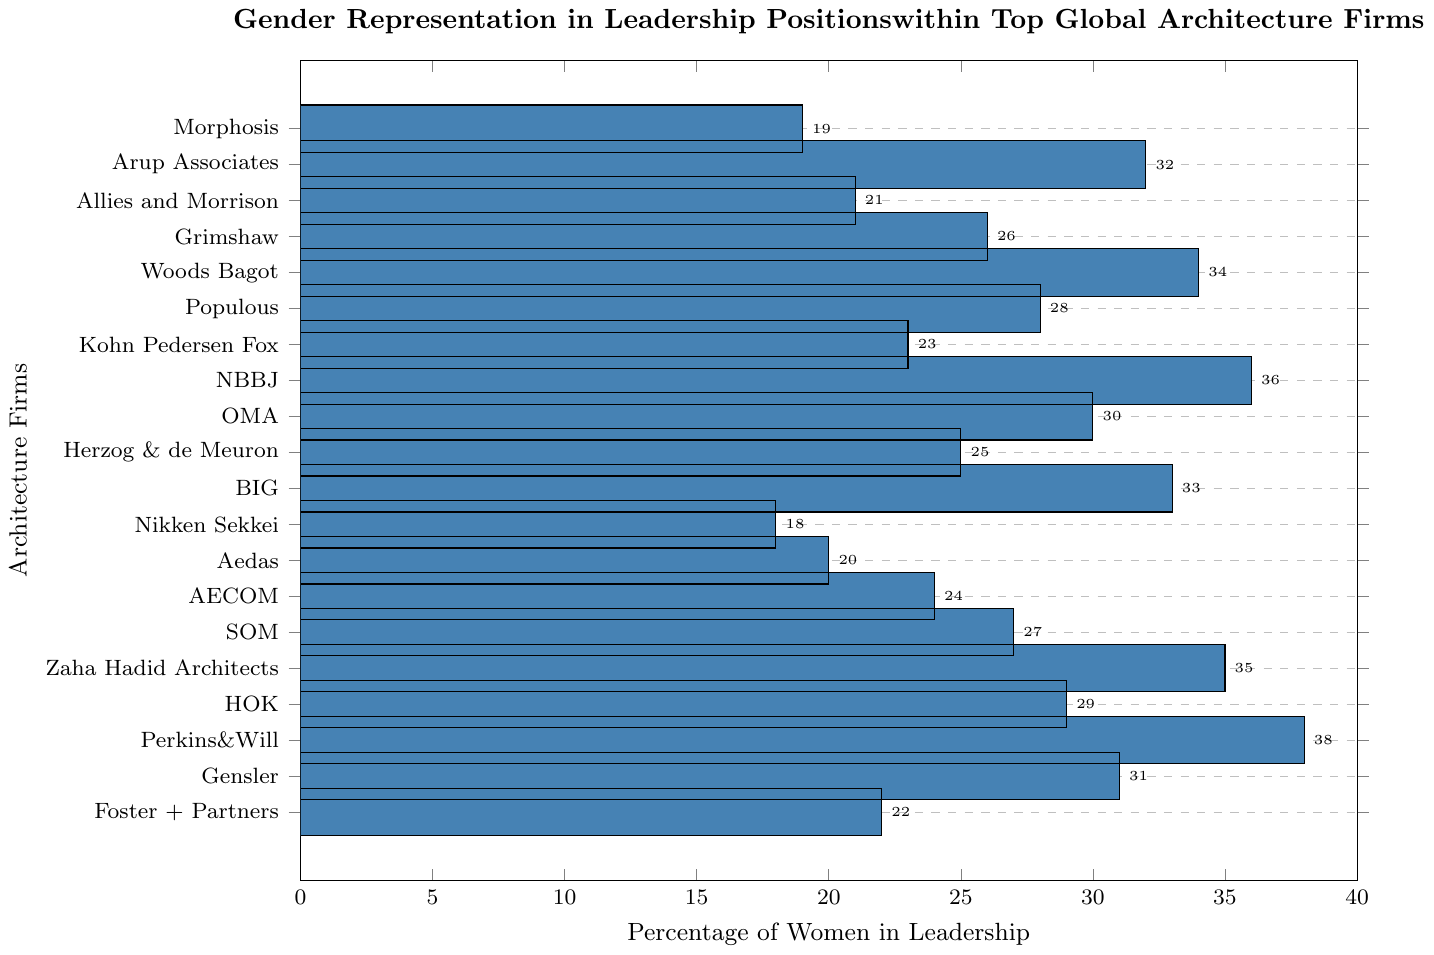Which firm has the highest percentage of women in leadership? The highest bar represents the firm with the highest percentage. Perkins & Will has the tallest bar at 38%.
Answer: Perkins & Will Which firm has the lowest percentage of women in leadership? The shortest bar represents the firm with the lowest percentage. Nikken Sekkei has the shortest bar at 18%.
Answer: Nikken Sekkei What is the difference in the percentage of women in leadership between Perkins & Will and Nikken Sekkei? Perkins & Will has 38% women in leadership, and Nikken Sekkei has 18%. The difference is 38% - 18% = 20%.
Answer: 20% Which firm has a percentage of women in leadership closest to 30%? Looking at the bars near 30%, OMA has 30% which is exactly 30%.
Answer: OMA How many firms have a percentage of women in leadership above 30%? Count the bars that exceed the 30% mark. Gensler, Perkins & Will, Zaha Hadid Architects, BIG, Woods Bagot, NBBJ, and Arup Associates are above 30%: 7 firms.
Answer: 7 What is the average percentage of women in leadership for Foster + Partners, Perkins + Will, and Gensler? Add the percentages and divide by the number of firms: (22% + 38% + 31%) / 3 = 91% / 3 = 30.33%.
Answer: 30.33% Are there more firms with a percentage of women in leadership below or above 25%? Count firms below 25% and firms above 25%. Below: Morphosis, Allies and Morrison, Aedas, AECOM, Foster + Partners, Kohn Pedersen Fox, Nikken Sekkei (7 firms). Above: Perkins & Will, Gensler, Zaha Hadid Architects, HOK, SOM, OMA, Populous, BIG, Woods Bagot, NBBJ, Grimshaw, Arup Associates (12 firms).
Answer: Above What is the median percentage of women in leadership across all firms? Arrange the values in ascending order and find the middle value(s): [18, 19, 20, 21, 22, 23, 24, 25, 26, 27, 28, 29, 30, 31, 32, 33, 34, 35, 36, 38]. There are 20 firms, so the median is the average of the 10th and 11th values: (27% + 28%) / 2 = 27.5%.
Answer: 27.5% What is the range of the percentage of women in leadership across the firms? Subtract the smallest percentage from the largest: 38% - 18% = 20%.
Answer: 20% 